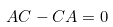<formula> <loc_0><loc_0><loc_500><loc_500>A C - C A = 0</formula> 